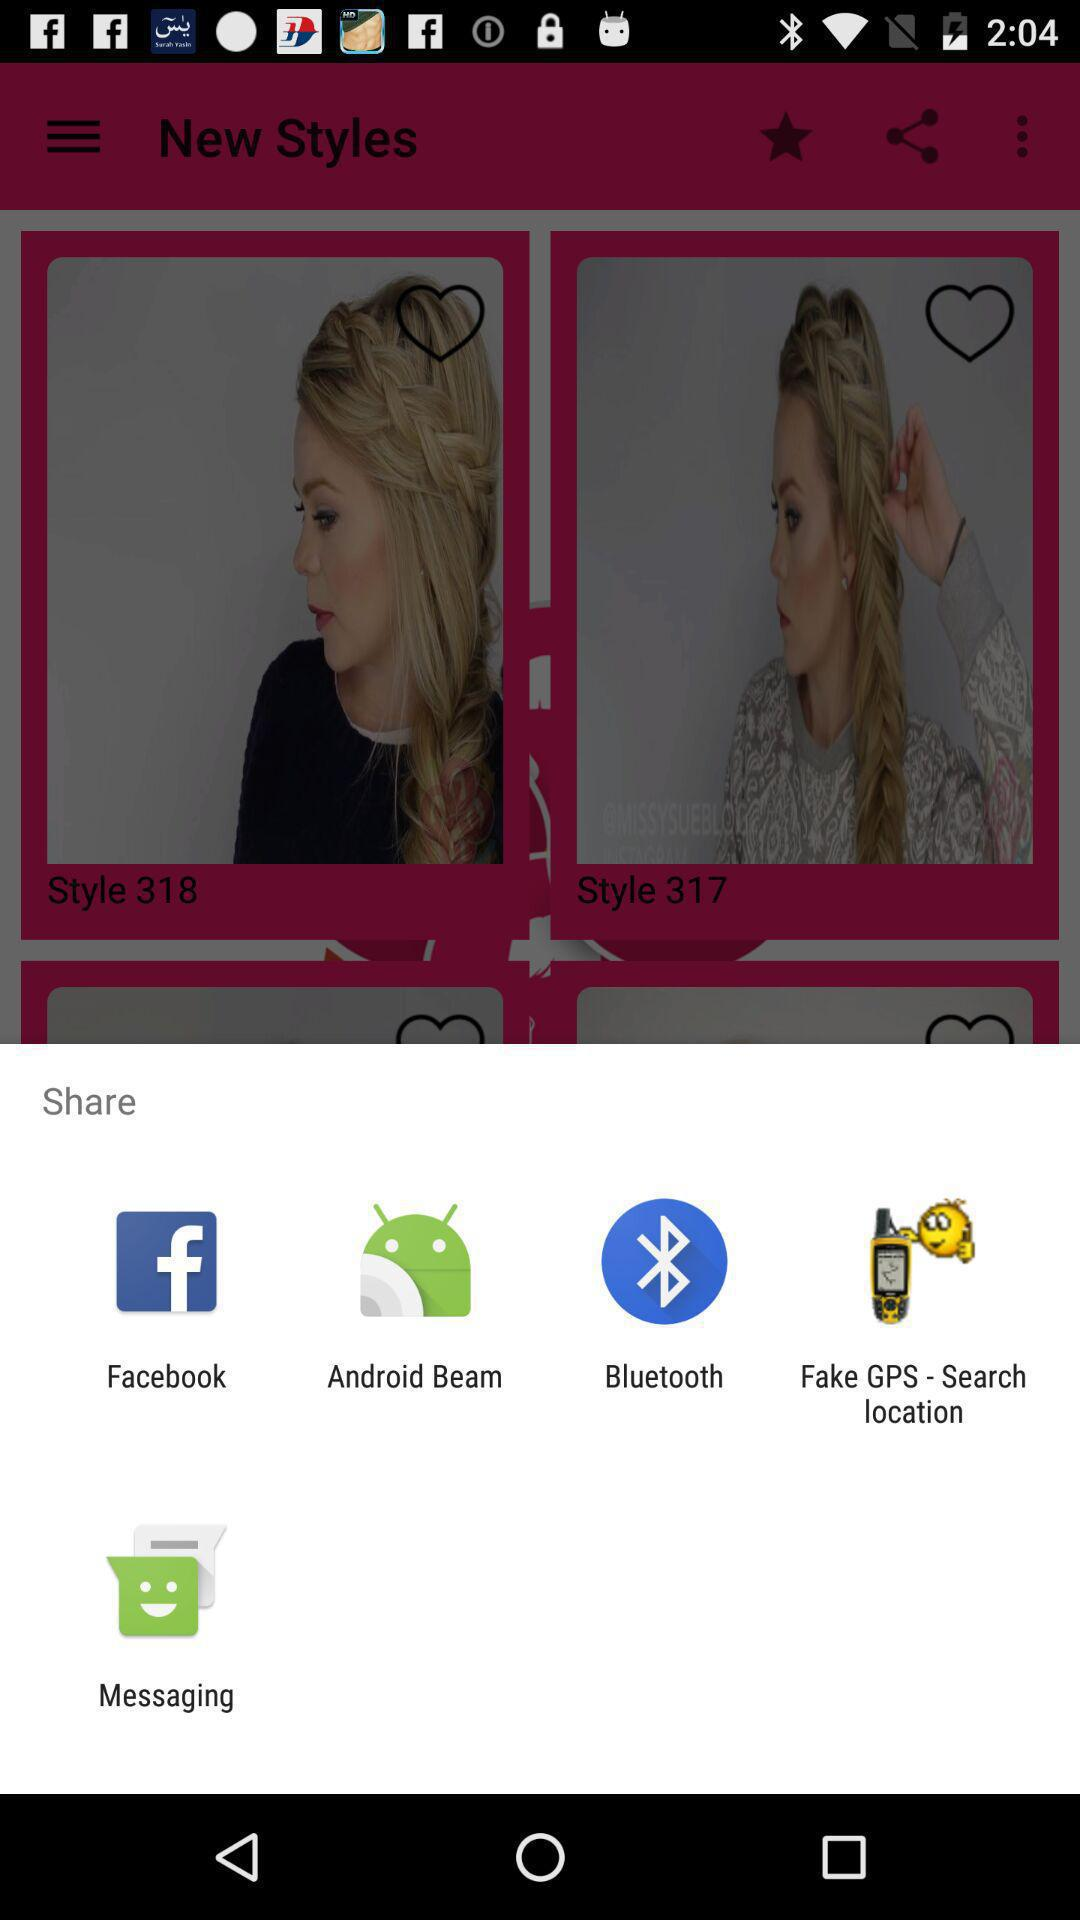Through which application can be shared? The sharing options are "Facebook", "Android Beam", "Bluetooth", "Fake GPS - Search location" and "Messaging". 